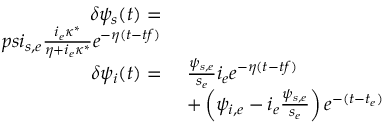Convert formula to latex. <formula><loc_0><loc_0><loc_500><loc_500>\begin{array} { r l } { \delta \psi _ { s } ( t ) = } \\ { p s i _ { s , e } \frac { i _ { e } \kappa ^ { * } } { \eta + i _ { e } \kappa ^ { * } } e ^ { - \eta ( t - t f ) } } \\ { \delta \psi _ { i } ( t ) = } & { \ \frac { \psi _ { s , e } } { s _ { e } } i _ { e } e ^ { - \eta ( t - t f ) } } \\ & { \ + \left ( \psi _ { i , e } - i _ { e } \frac { \psi _ { s , e } } { s _ { e } } \right ) e ^ { - ( t - t _ { e } ) } } \end{array}</formula> 